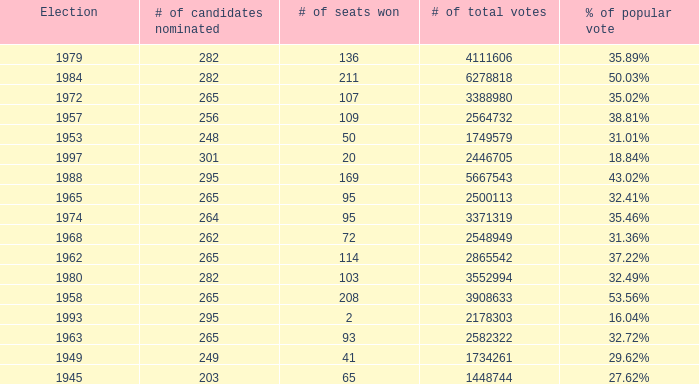I'm looking to parse the entire table for insights. Could you assist me with that? {'header': ['Election', '# of candidates nominated', '# of seats won', '# of total votes', '% of popular vote'], 'rows': [['1979', '282', '136', '4111606', '35.89%'], ['1984', '282', '211', '6278818', '50.03%'], ['1972', '265', '107', '3388980', '35.02%'], ['1957', '256', '109', '2564732', '38.81%'], ['1953', '248', '50', '1749579', '31.01%'], ['1997', '301', '20', '2446705', '18.84%'], ['1988', '295', '169', '5667543', '43.02%'], ['1965', '265', '95', '2500113', '32.41%'], ['1974', '264', '95', '3371319', '35.46%'], ['1968', '262', '72', '2548949', '31.36%'], ['1962', '265', '114', '2865542', '37.22%'], ['1980', '282', '103', '3552994', '32.49%'], ['1958', '265', '208', '3908633', '53.56%'], ['1993', '295', '2', '2178303', '16.04%'], ['1963', '265', '93', '2582322', '32.72%'], ['1949', '249', '41', '1734261', '29.62%'], ['1945', '203', '65', '1448744', '27.62%']]} What was the lowest # of total votes? 1448744.0. 